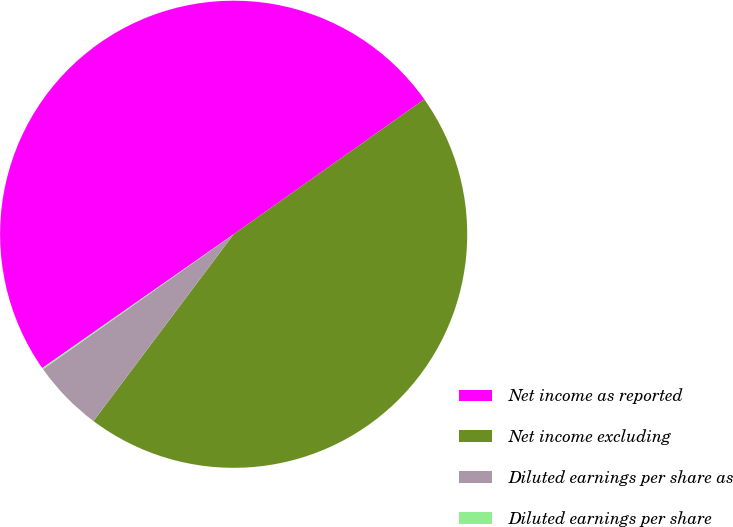<chart> <loc_0><loc_0><loc_500><loc_500><pie_chart><fcel>Net income as reported<fcel>Net income excluding<fcel>Diluted earnings per share as<fcel>Diluted earnings per share<nl><fcel>49.91%<fcel>45.05%<fcel>4.95%<fcel>0.09%<nl></chart> 